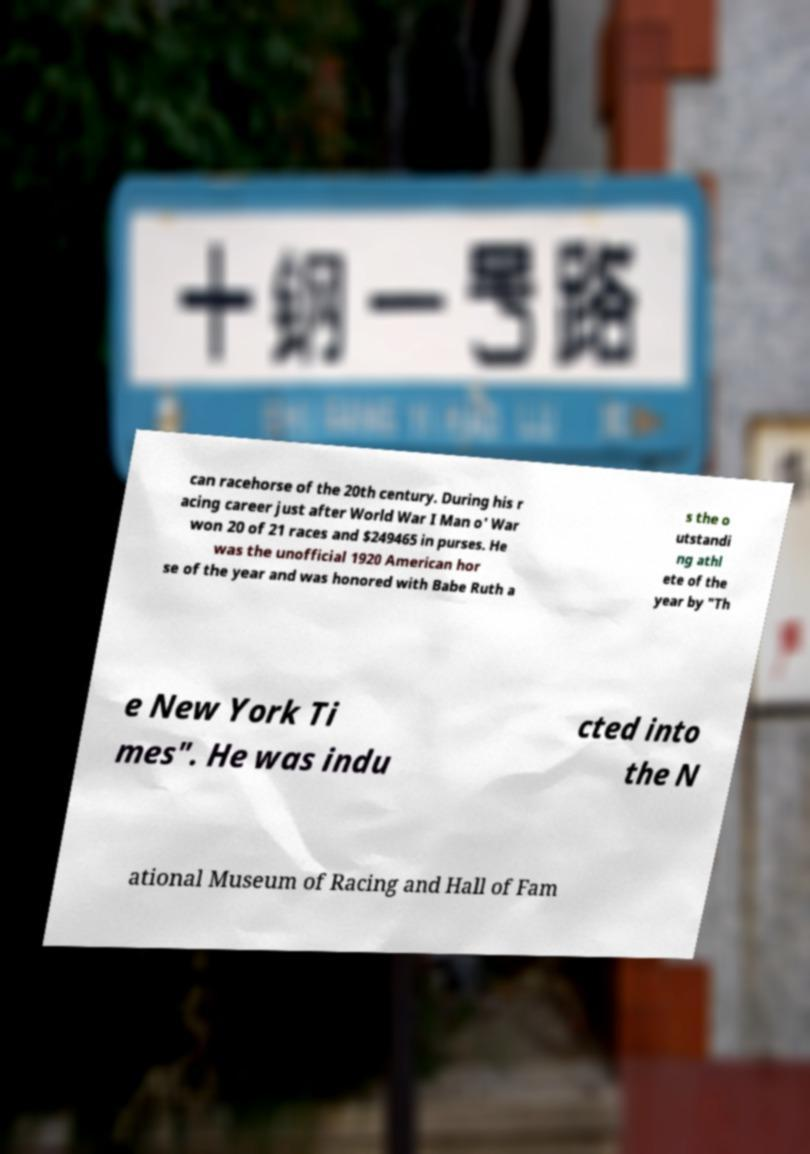I need the written content from this picture converted into text. Can you do that? can racehorse of the 20th century. During his r acing career just after World War I Man o' War won 20 of 21 races and $249465 in purses. He was the unofficial 1920 American hor se of the year and was honored with Babe Ruth a s the o utstandi ng athl ete of the year by "Th e New York Ti mes". He was indu cted into the N ational Museum of Racing and Hall of Fam 